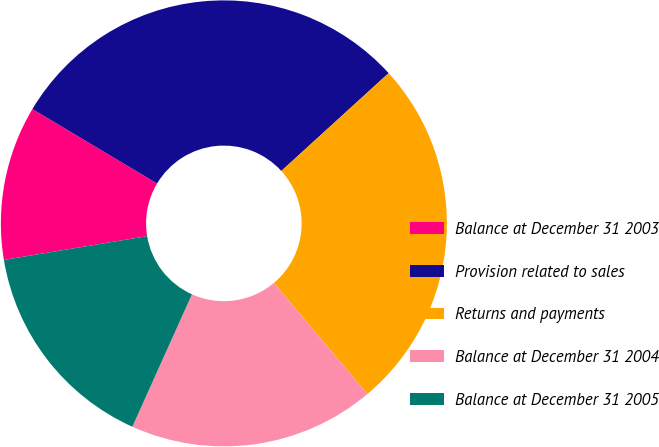Convert chart. <chart><loc_0><loc_0><loc_500><loc_500><pie_chart><fcel>Balance at December 31 2003<fcel>Provision related to sales<fcel>Returns and payments<fcel>Balance at December 31 2004<fcel>Balance at December 31 2005<nl><fcel>11.19%<fcel>29.67%<fcel>25.64%<fcel>17.86%<fcel>15.65%<nl></chart> 